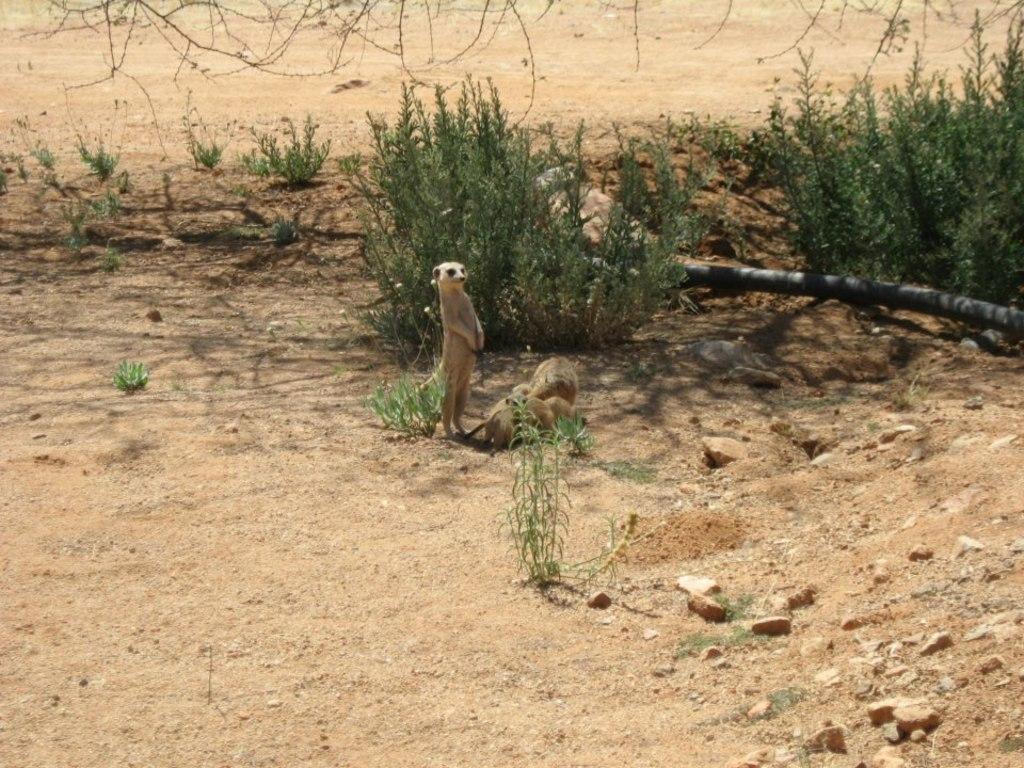In one or two sentences, can you explain what this image depicts? In the image there is a ground and there are some animals on the ground, behind the animals there are small plants. 